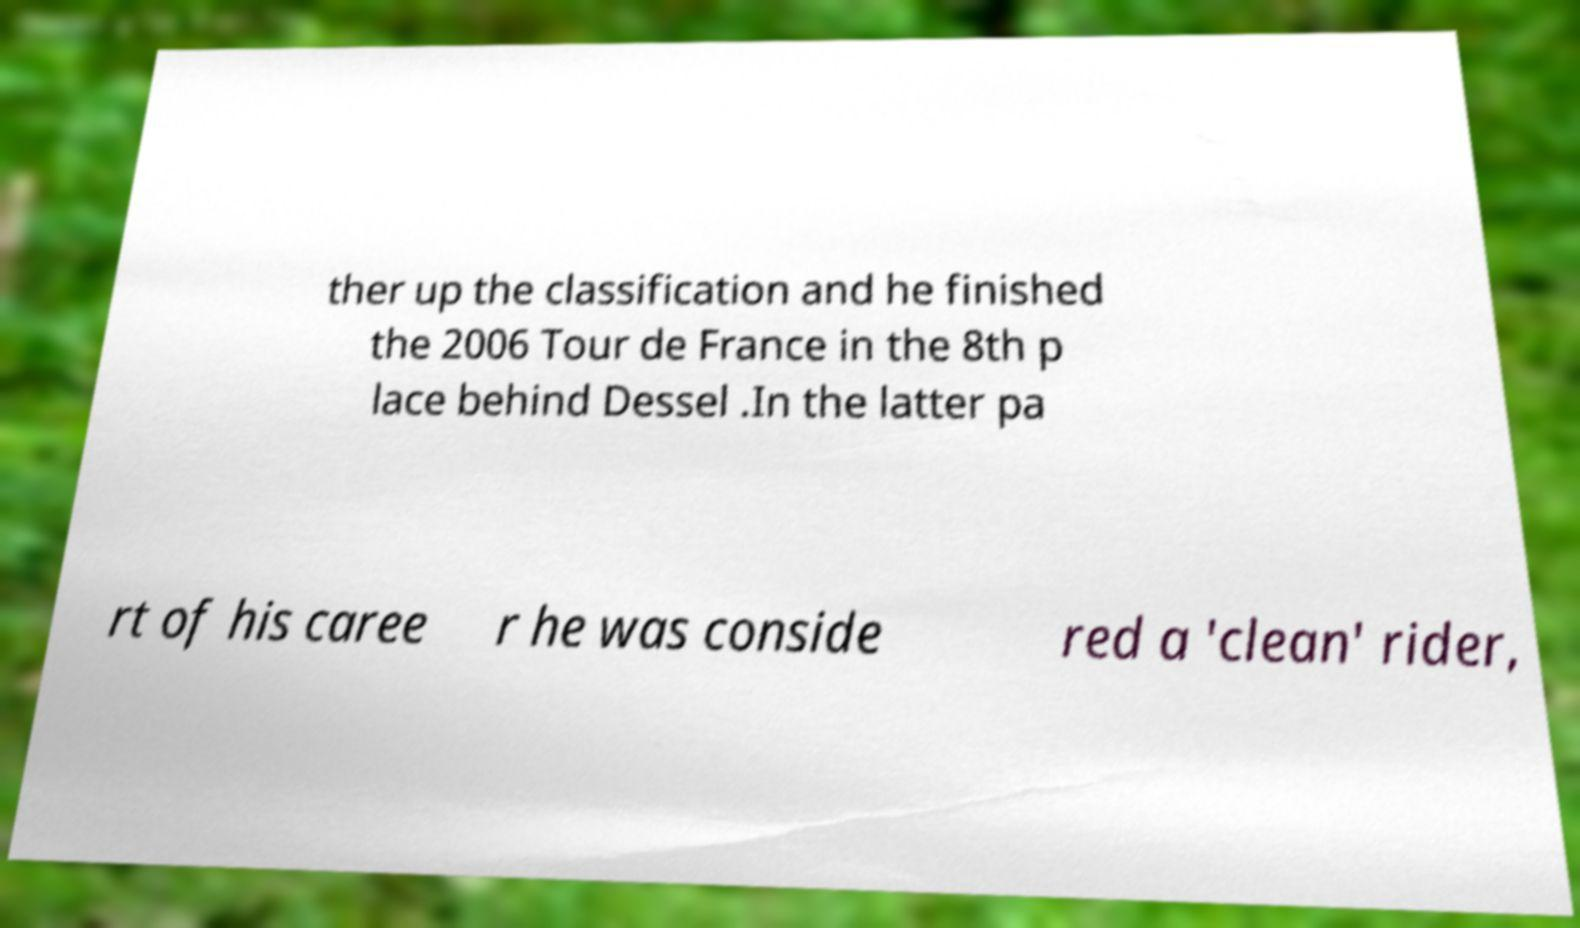Could you extract and type out the text from this image? ther up the classification and he finished the 2006 Tour de France in the 8th p lace behind Dessel .In the latter pa rt of his caree r he was conside red a 'clean' rider, 